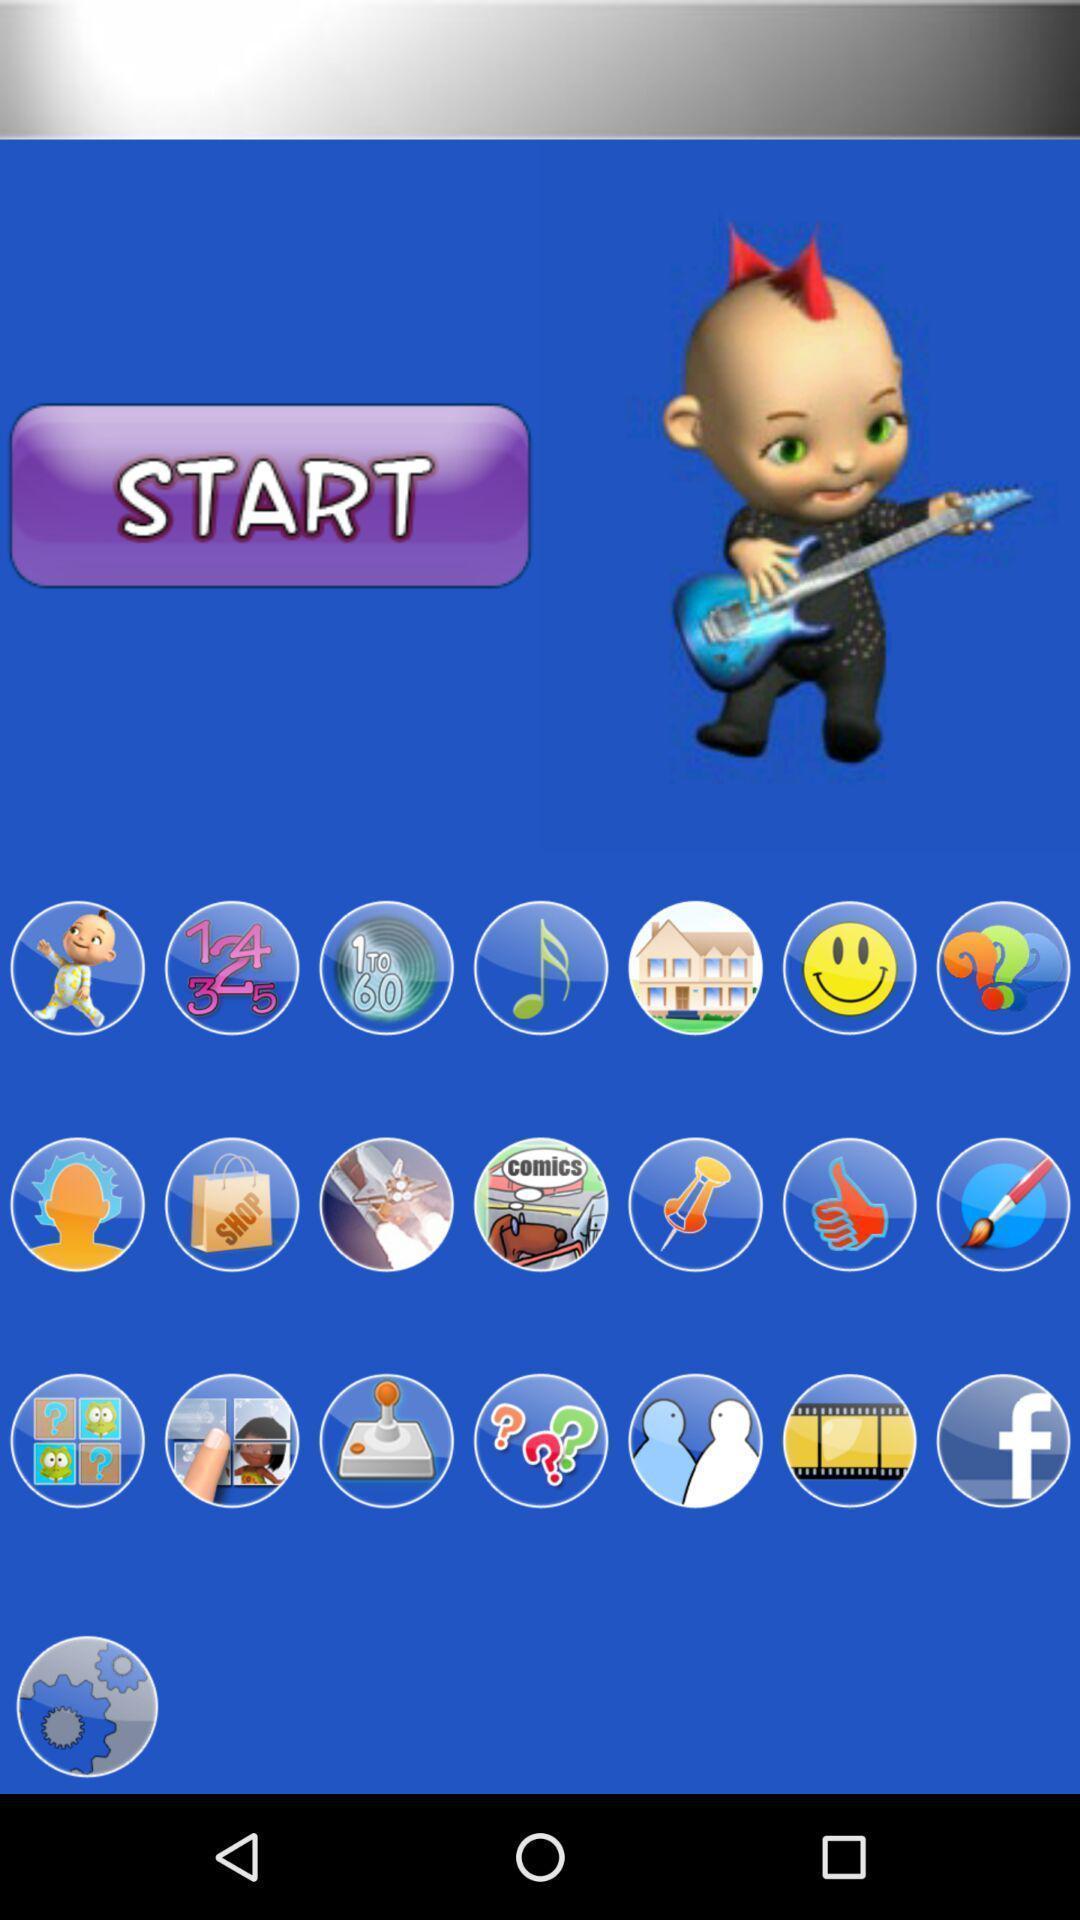Summarize the main components in this picture. Starting page of a gaming app. 